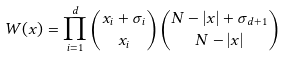<formula> <loc_0><loc_0><loc_500><loc_500>W ( x ) = \prod _ { i = 1 } ^ { d } \binom { x _ { i } + \sigma _ { i } } { x _ { i } } \binom { N - | x | + \sigma _ { d + 1 } } { N - | x | }</formula> 